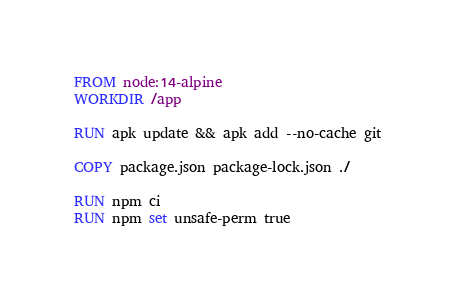Convert code to text. <code><loc_0><loc_0><loc_500><loc_500><_Dockerfile_>FROM node:14-alpine
WORKDIR /app

RUN apk update && apk add --no-cache git

COPY package.json package-lock.json ./

RUN npm ci
RUN npm set unsafe-perm true
</code> 